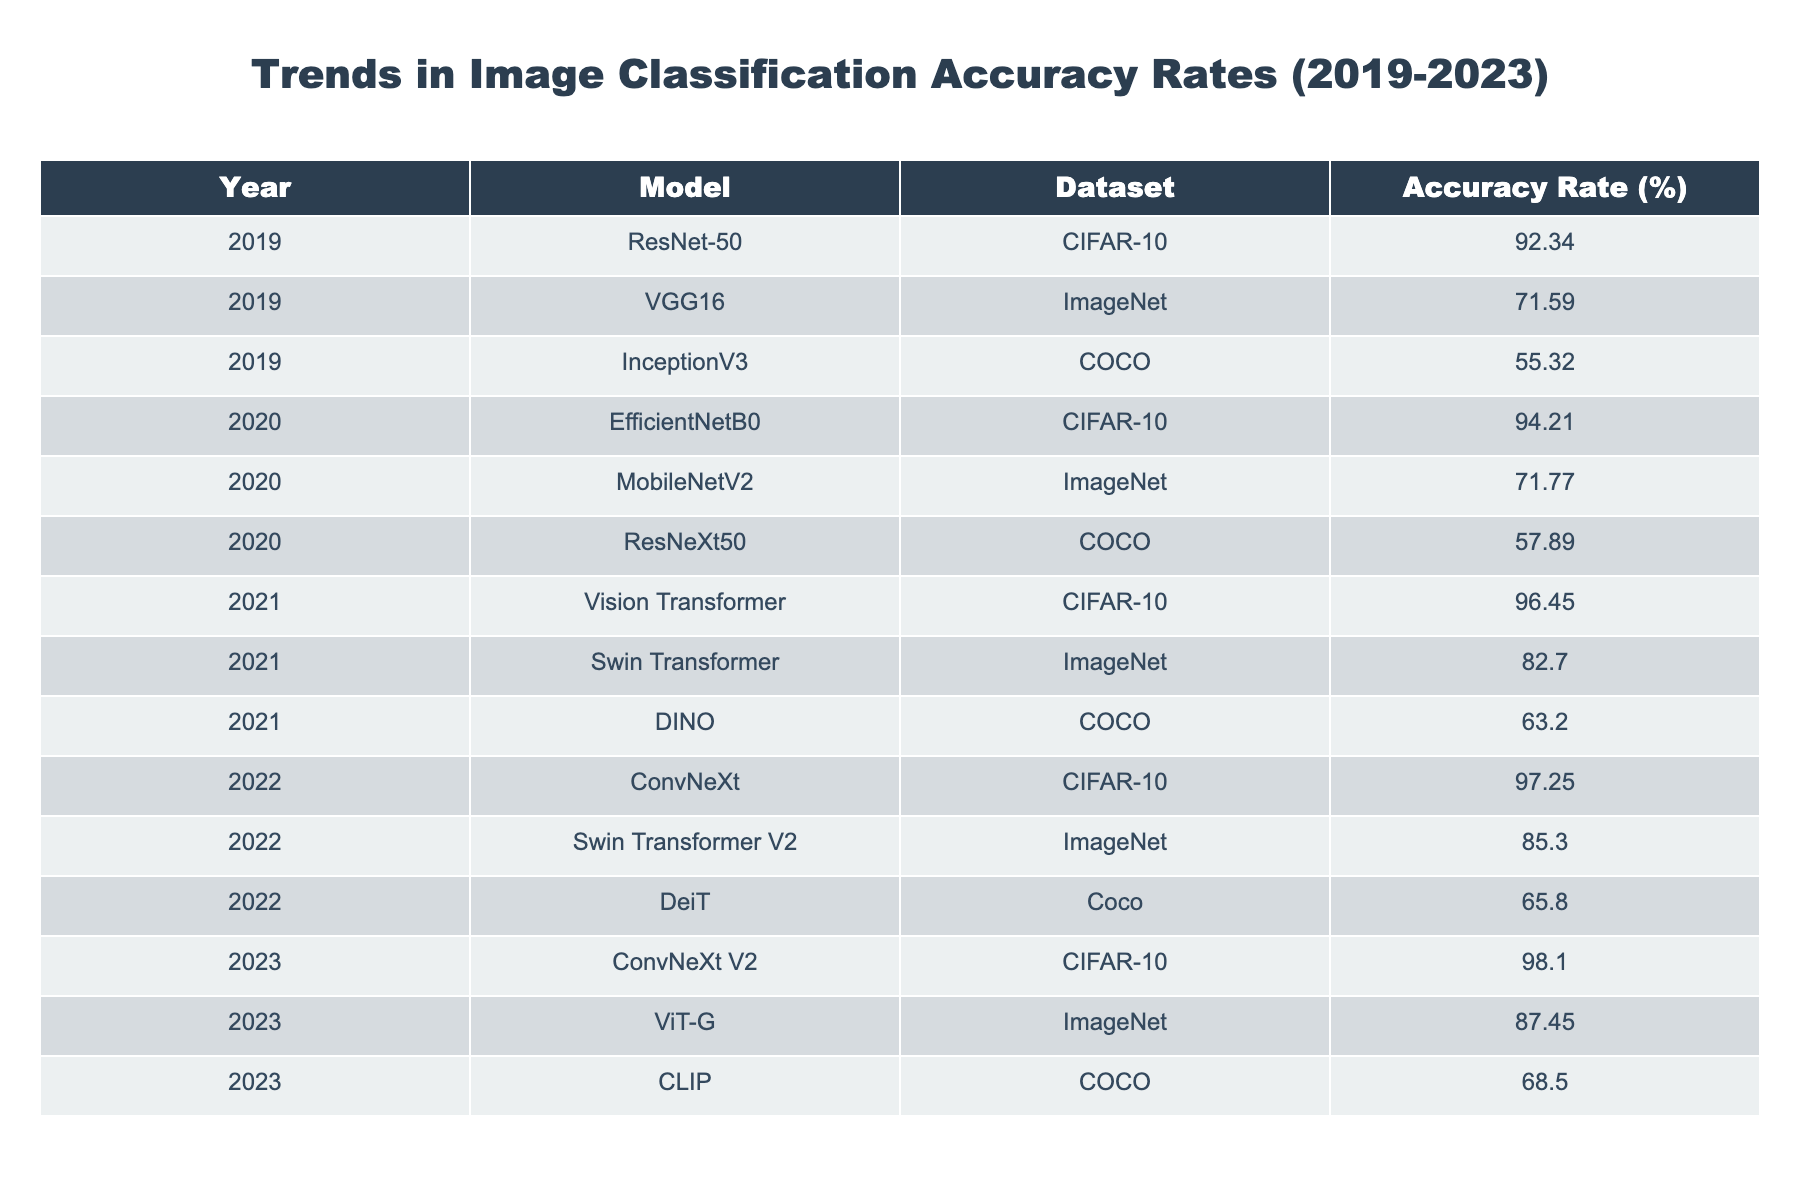What model achieved the highest accuracy rate in 2023? In 2023, the models listed are ConvNeXt V2, ViT-G, and CLIP. Among these, ConvNeXt V2 achieved the highest accuracy rate of 98.10%.
Answer: 98.10% Which dataset did the ResNet-50 model use? The ResNet-50 model, as indicated in the table, utilized the CIFAR-10 dataset.
Answer: CIFAR-10 What was the average accuracy rate of models using the COCO dataset from 2019 to 2023? The accuracy rates for the COCO dataset over the years are 55.32 (2019), 57.89 (2020), 63.20 (2021), 65.80 (2022), and 68.50 (2023). Summing these gives 55.32 + 57.89 + 63.20 + 65.80 + 68.50 = 310.71, and the average is 310.71 / 5 = 62.142.
Answer: 62.14 Did any model in 2021 have an accuracy rate of over 70%? In 2021, the models listed are Vision Transformer (96.45%), Swin Transformer (82.70%), and DINO (63.20%). Both Vision Transformer and Swin Transformer had accuracy rates greater than 70%.
Answer: Yes Which model had the biggest improvement in accuracy rate from 2019 to 2023 in the CIFAR-10 dataset? The models that used the CIFAR-10 dataset are ResNet-50 (92.34% in 2019), EfficientNetB0 (94.21% in 2020), Vision Transformer (96.45% in 2021), ConvNeXt (97.25% in 2022), and ConvNeXt V2 (98.10% in 2023). The improvement from 2019 to 2023 can be calculated as 98.10 - 92.34 = 5.76. The model with the highest accuracy in 2019 was ResNet-50, and it also had significant improvement over the years, reaching 98.10% in 2023.
Answer: ConvNeXt V2 What was the accuracy rate of MobileNetV2 in 2020? Referring to the table, MobileNetV2's accuracy rate in 2020 is clearly indicated as 71.77%.
Answer: 71.77% 